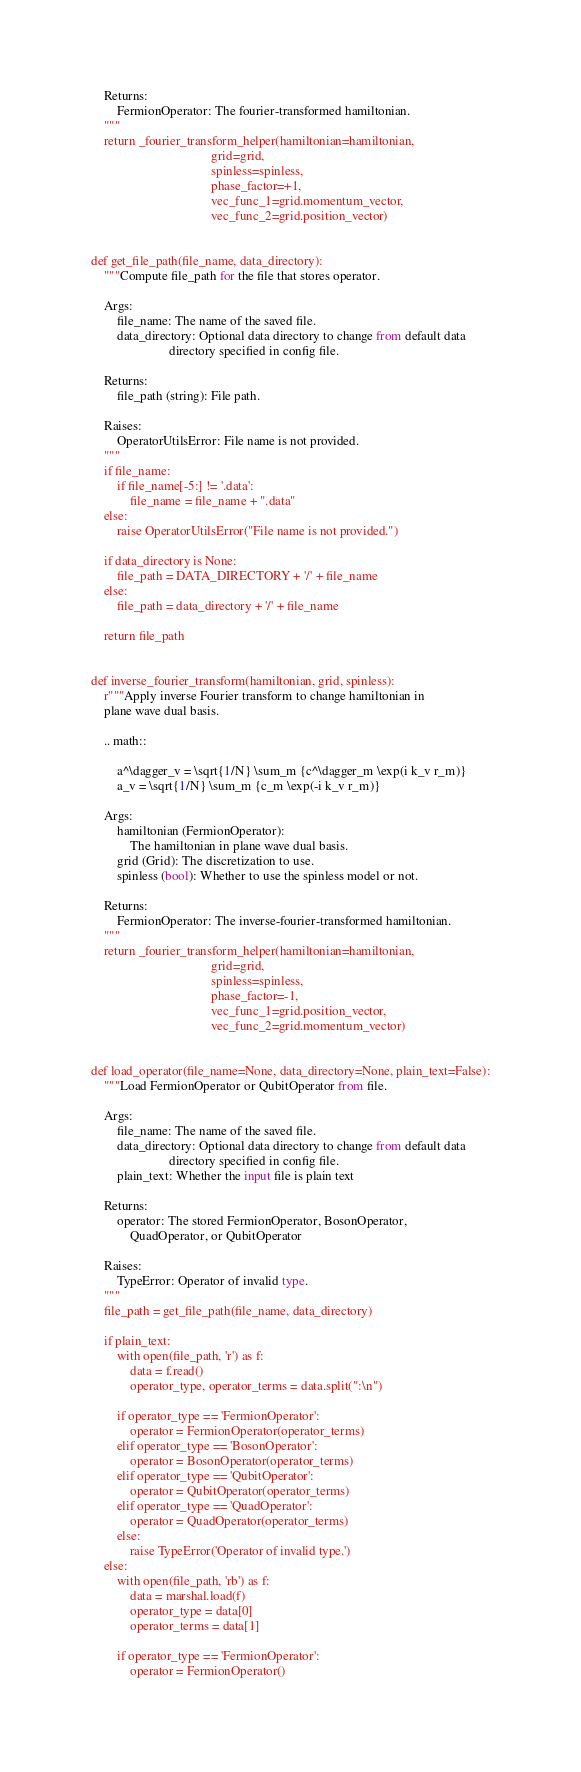<code> <loc_0><loc_0><loc_500><loc_500><_Python_>    Returns:
        FermionOperator: The fourier-transformed hamiltonian.
    """
    return _fourier_transform_helper(hamiltonian=hamiltonian,
                                     grid=grid,
                                     spinless=spinless,
                                     phase_factor=+1,
                                     vec_func_1=grid.momentum_vector,
                                     vec_func_2=grid.position_vector)


def get_file_path(file_name, data_directory):
    """Compute file_path for the file that stores operator.

    Args:
        file_name: The name of the saved file.
        data_directory: Optional data directory to change from default data
                        directory specified in config file.

    Returns:
        file_path (string): File path.

    Raises:
        OperatorUtilsError: File name is not provided.
    """
    if file_name:
        if file_name[-5:] != '.data':
            file_name = file_name + ".data"
    else:
        raise OperatorUtilsError("File name is not provided.")

    if data_directory is None:
        file_path = DATA_DIRECTORY + '/' + file_name
    else:
        file_path = data_directory + '/' + file_name

    return file_path


def inverse_fourier_transform(hamiltonian, grid, spinless):
    r"""Apply inverse Fourier transform to change hamiltonian in
    plane wave dual basis.

    .. math::

        a^\dagger_v = \sqrt{1/N} \sum_m {c^\dagger_m \exp(i k_v r_m)}
        a_v = \sqrt{1/N} \sum_m {c_m \exp(-i k_v r_m)}

    Args:
        hamiltonian (FermionOperator):
            The hamiltonian in plane wave dual basis.
        grid (Grid): The discretization to use.
        spinless (bool): Whether to use the spinless model or not.

    Returns:
        FermionOperator: The inverse-fourier-transformed hamiltonian.
    """
    return _fourier_transform_helper(hamiltonian=hamiltonian,
                                     grid=grid,
                                     spinless=spinless,
                                     phase_factor=-1,
                                     vec_func_1=grid.position_vector,
                                     vec_func_2=grid.momentum_vector)


def load_operator(file_name=None, data_directory=None, plain_text=False):
    """Load FermionOperator or QubitOperator from file.

    Args:
        file_name: The name of the saved file.
        data_directory: Optional data directory to change from default data
                        directory specified in config file.
        plain_text: Whether the input file is plain text

    Returns:
        operator: The stored FermionOperator, BosonOperator,
            QuadOperator, or QubitOperator

    Raises:
        TypeError: Operator of invalid type.
    """
    file_path = get_file_path(file_name, data_directory)

    if plain_text:
        with open(file_path, 'r') as f:
            data = f.read()
            operator_type, operator_terms = data.split(":\n")

        if operator_type == 'FermionOperator':
            operator = FermionOperator(operator_terms)
        elif operator_type == 'BosonOperator':
            operator = BosonOperator(operator_terms)
        elif operator_type == 'QubitOperator':
            operator = QubitOperator(operator_terms)
        elif operator_type == 'QuadOperator':
            operator = QuadOperator(operator_terms)
        else:
            raise TypeError('Operator of invalid type.')
    else:
        with open(file_path, 'rb') as f:
            data = marshal.load(f)
            operator_type = data[0]
            operator_terms = data[1]

        if operator_type == 'FermionOperator':
            operator = FermionOperator()</code> 